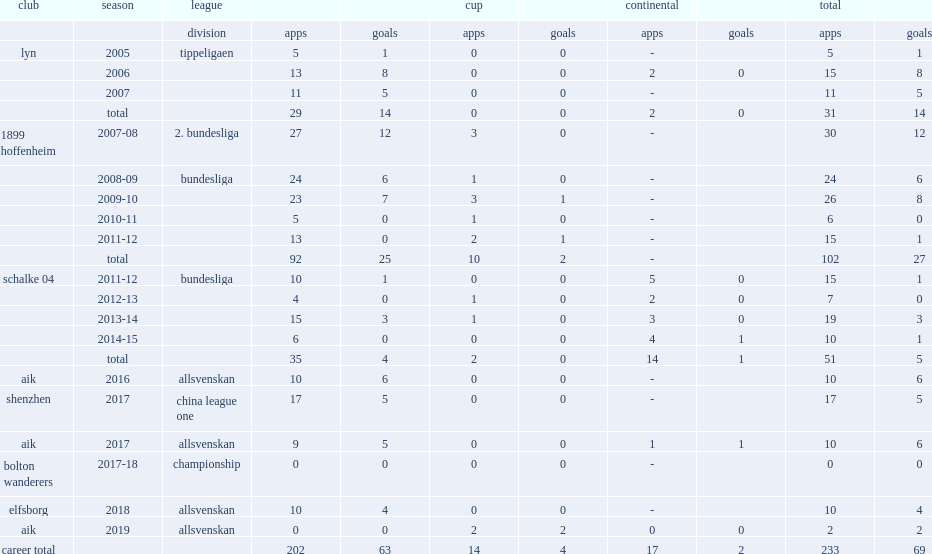Which division did chinedu obasi play for shenzhen in 2017? China league one. 